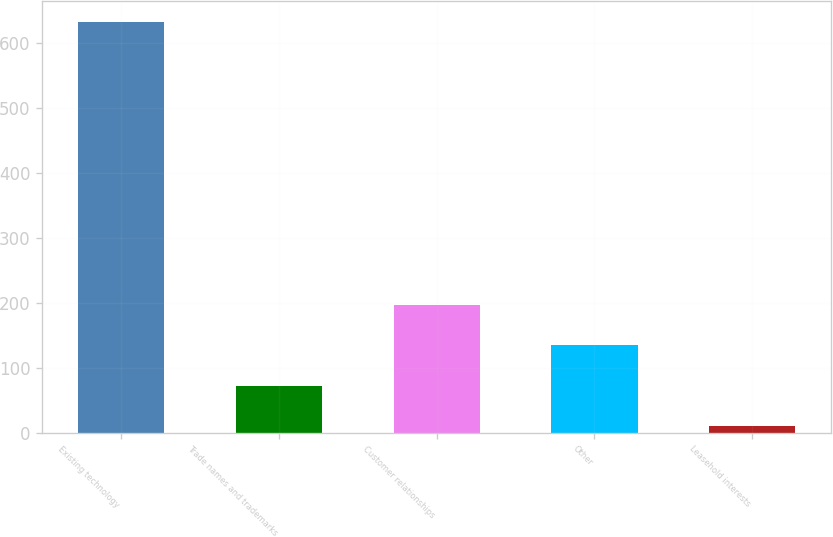Convert chart. <chart><loc_0><loc_0><loc_500><loc_500><bar_chart><fcel>Existing technology<fcel>Trade names and trademarks<fcel>Customer relationships<fcel>Other<fcel>Leasehold interests<nl><fcel>632<fcel>72.2<fcel>196.6<fcel>134.4<fcel>10<nl></chart> 